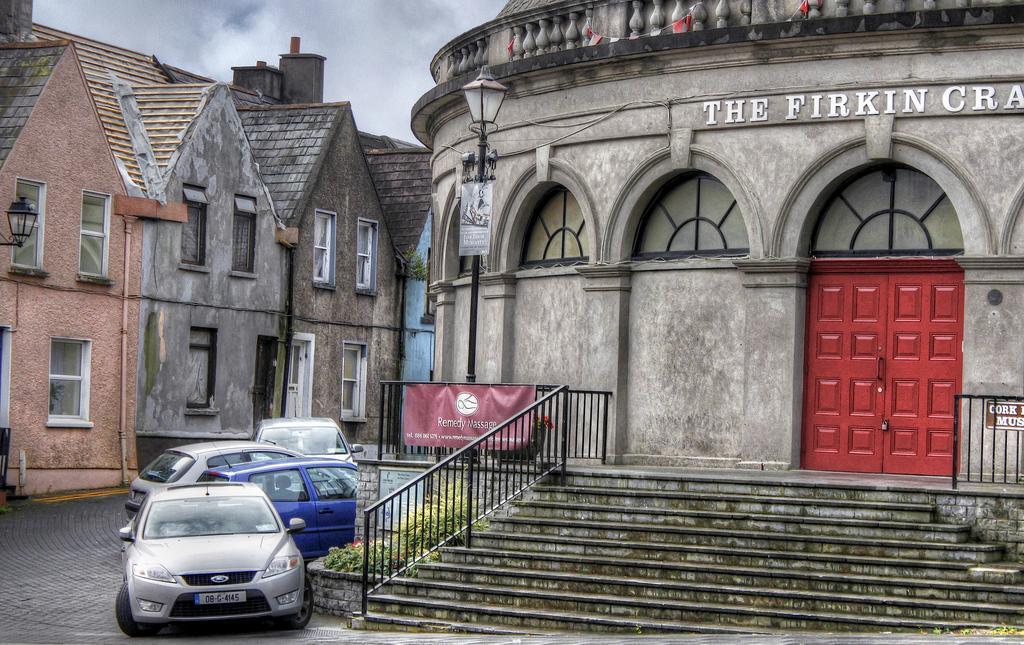Can you describe this image briefly? In this image I can see a car which is silver in color and a car which is blue in color and few other cars on the road. I can see few stairs, the railing, a red colored banner and a red colored door to the building. I can see few buildings and a street light pole which is black in color. In the background I can see the sky. 